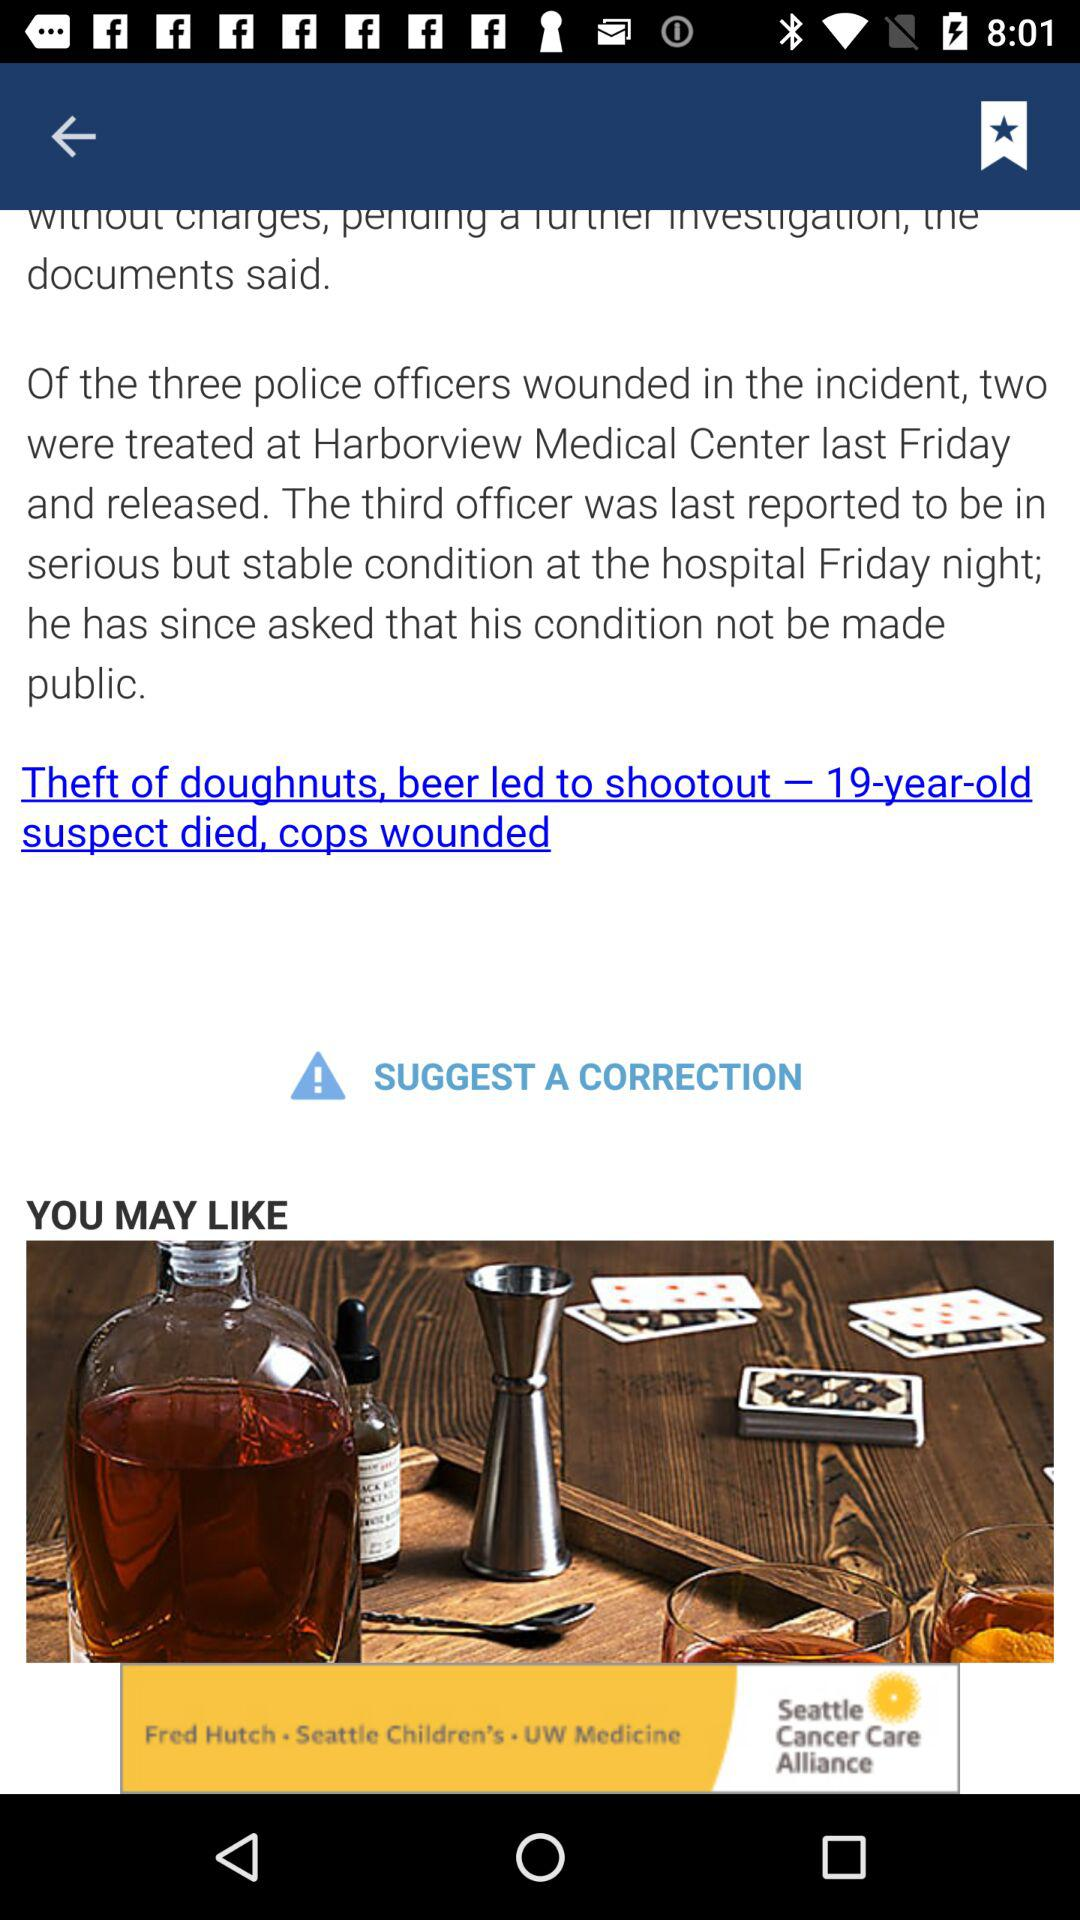What is the age of the suspect who died? The suspect who died is 19 years old. 